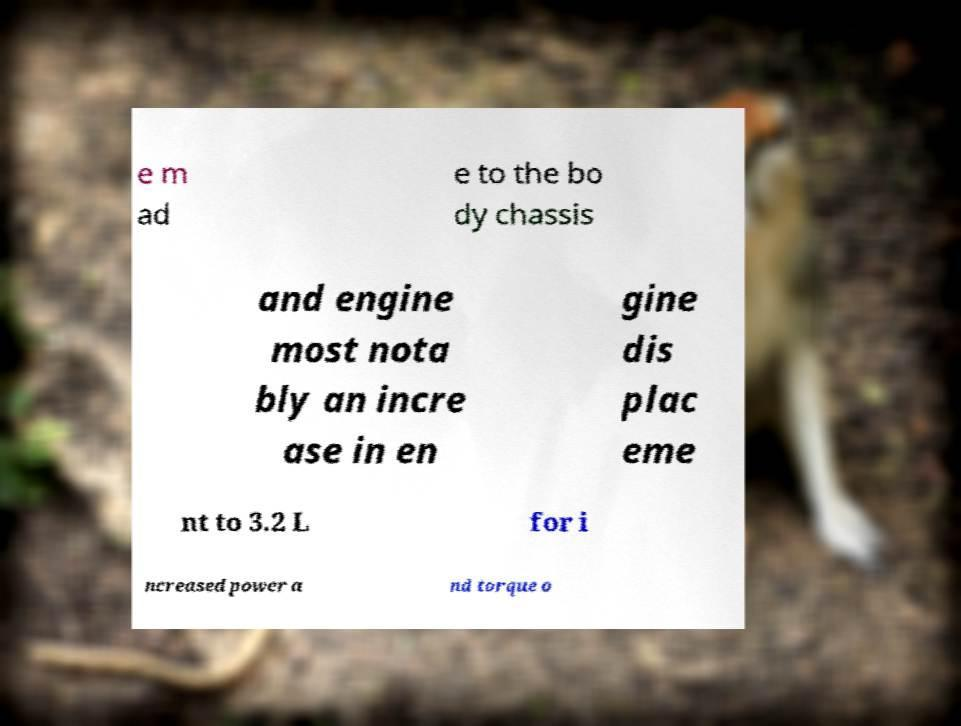I need the written content from this picture converted into text. Can you do that? e m ad e to the bo dy chassis and engine most nota bly an incre ase in en gine dis plac eme nt to 3.2 L for i ncreased power a nd torque o 